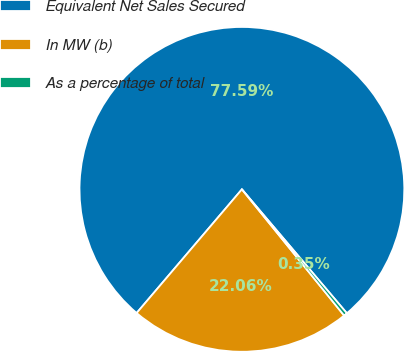Convert chart. <chart><loc_0><loc_0><loc_500><loc_500><pie_chart><fcel>Equivalent Net Sales Secured<fcel>In MW (b)<fcel>As a percentage of total<nl><fcel>77.59%<fcel>22.06%<fcel>0.35%<nl></chart> 